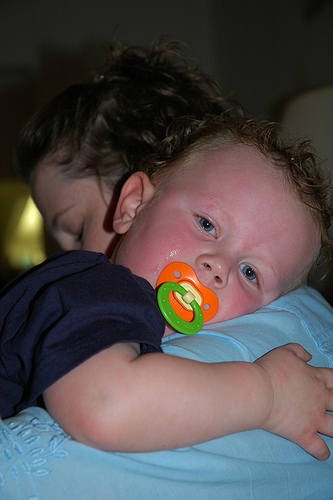<image>
Is there a pacifier in the baby? Yes. The pacifier is contained within or inside the baby, showing a containment relationship. 